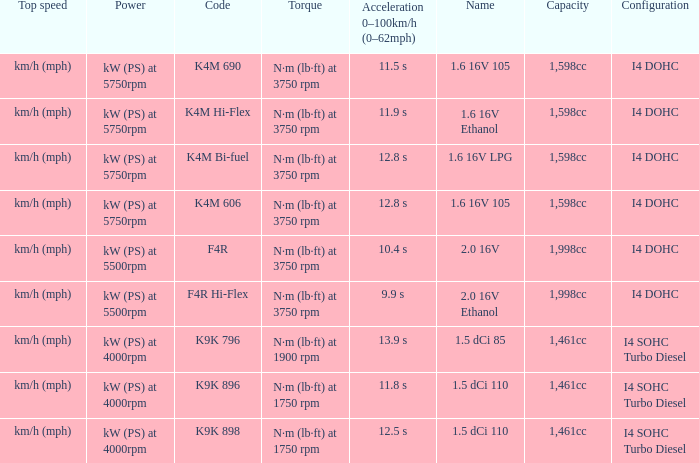What is the capacity of code f4r? 1,998cc. 